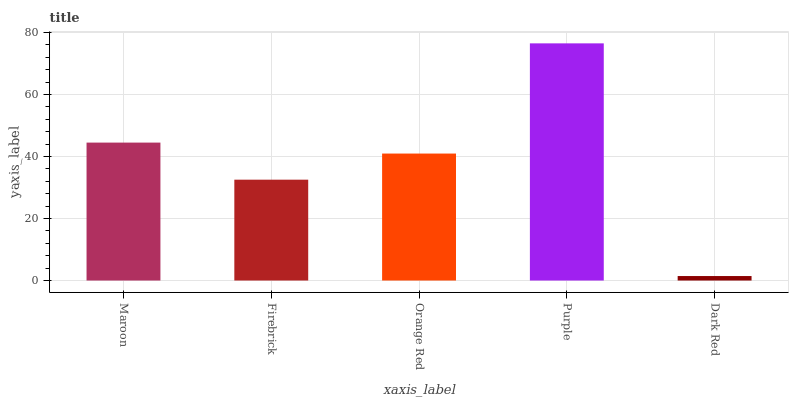Is Dark Red the minimum?
Answer yes or no. Yes. Is Purple the maximum?
Answer yes or no. Yes. Is Firebrick the minimum?
Answer yes or no. No. Is Firebrick the maximum?
Answer yes or no. No. Is Maroon greater than Firebrick?
Answer yes or no. Yes. Is Firebrick less than Maroon?
Answer yes or no. Yes. Is Firebrick greater than Maroon?
Answer yes or no. No. Is Maroon less than Firebrick?
Answer yes or no. No. Is Orange Red the high median?
Answer yes or no. Yes. Is Orange Red the low median?
Answer yes or no. Yes. Is Firebrick the high median?
Answer yes or no. No. Is Purple the low median?
Answer yes or no. No. 